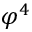Convert formula to latex. <formula><loc_0><loc_0><loc_500><loc_500>\varphi ^ { 4 }</formula> 